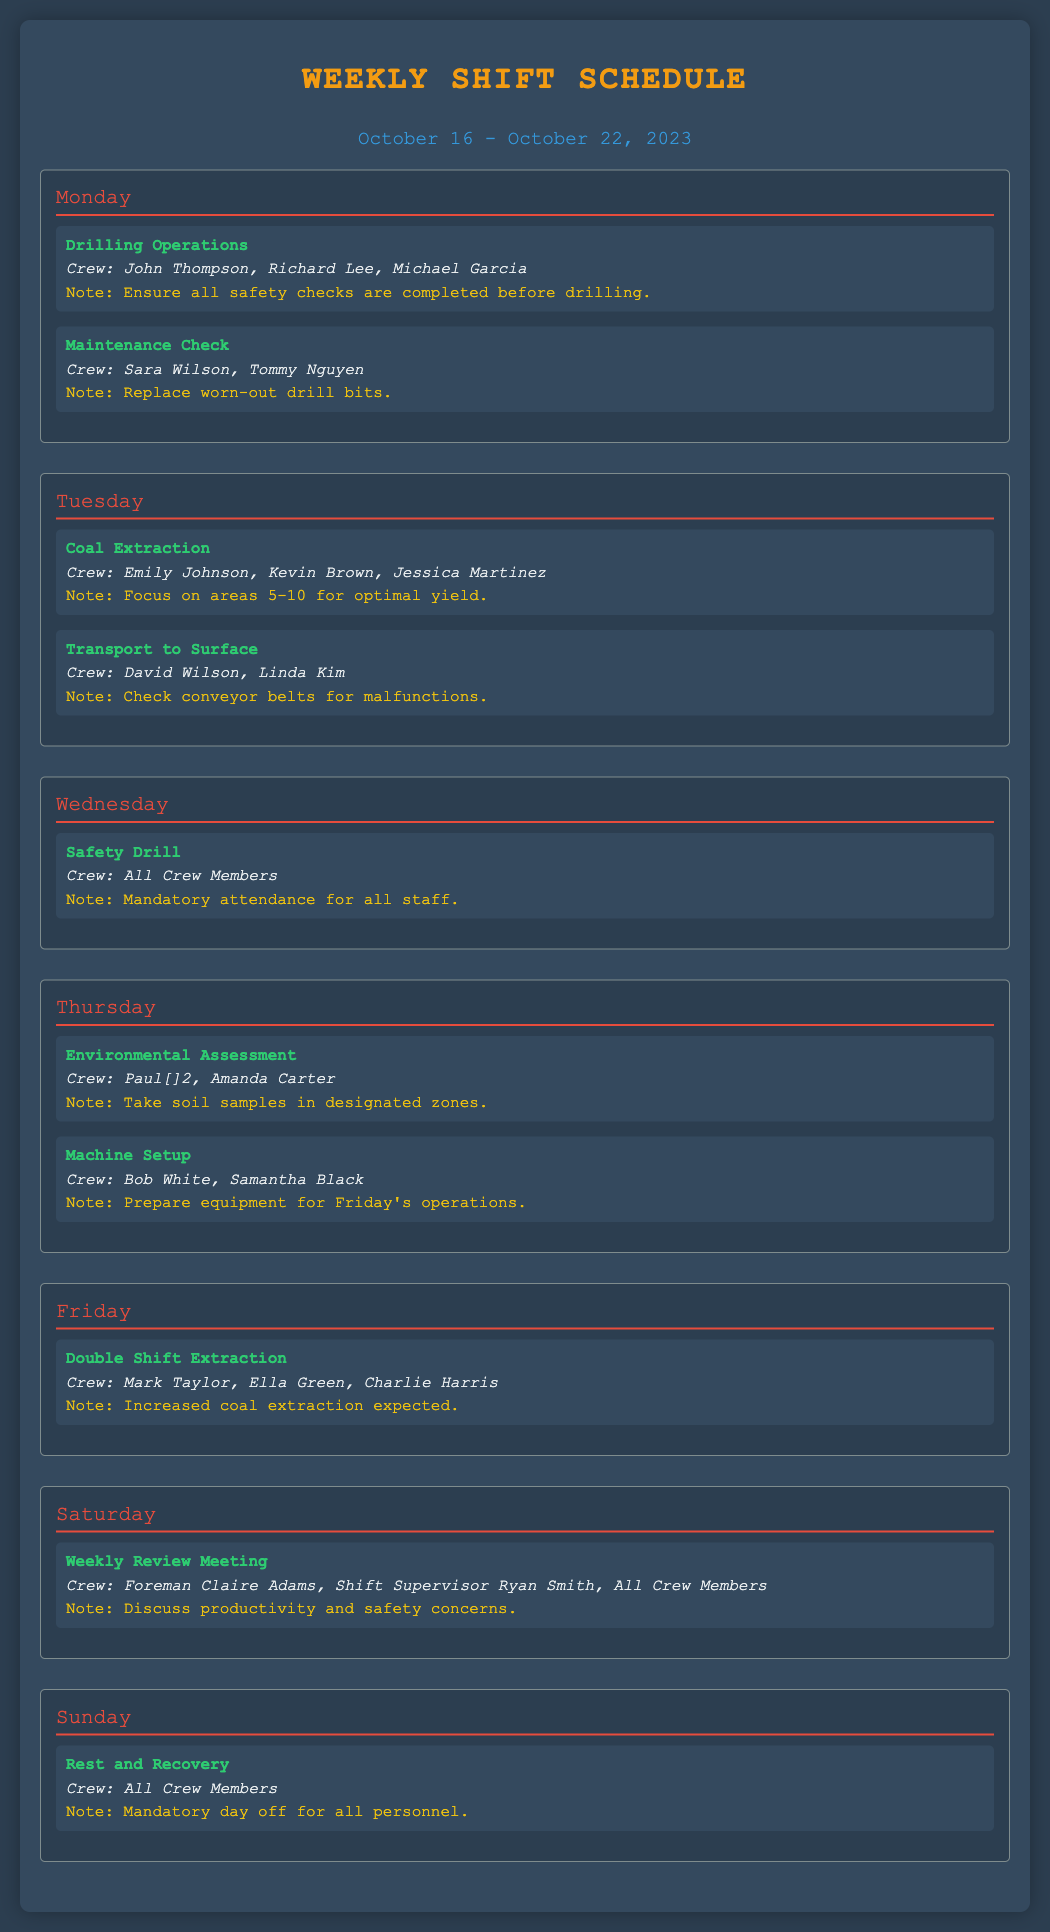What is the focus area for coal extraction on Tuesday? The focus areas for coal extraction on Tuesday are specified as areas 5-10 in the document.
Answer: areas 5-10 Who are the crew members for the Safety Drill on Wednesday? The Safety Drill on Wednesday requires the attendance of all crew members.
Answer: All Crew Members What task is scheduled for Thursday that involves preparing equipment? The task scheduled for Thursday that involves preparing equipment is the Machine Setup.
Answer: Machine Setup What day is designated for Rest and Recovery? The document specifies Sunday as the designated day for Rest and Recovery for all personnel.
Answer: Sunday Which crew members are involved in the Weekly Review Meeting? The crew members involved in the Weekly Review Meeting include the Foreman, the Shift Supervisor, and all crew members.
Answer: Foreman Claire Adams, Shift Supervisor Ryan Smith, All Crew Members What is a key note regarding the Drilling Operations on Monday? A key note regarding the Drilling Operations on Monday is to ensure all safety checks are completed before drilling begins.
Answer: Ensure all safety checks What type of assessment is being conducted on Thursday? The type of assessment being conducted on Thursday is an Environmental Assessment.
Answer: Environmental Assessment How many tasks are assigned for Friday? There is one task assigned for Friday, which is the Double Shift Extraction.
Answer: One What note is provided for Maintenance Check on Monday? The note for Maintenance Check on Monday is to replace worn-out drill bits.
Answer: Replace worn-out drill bits 